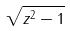Convert formula to latex. <formula><loc_0><loc_0><loc_500><loc_500>\sqrt { z ^ { 2 } - 1 }</formula> 